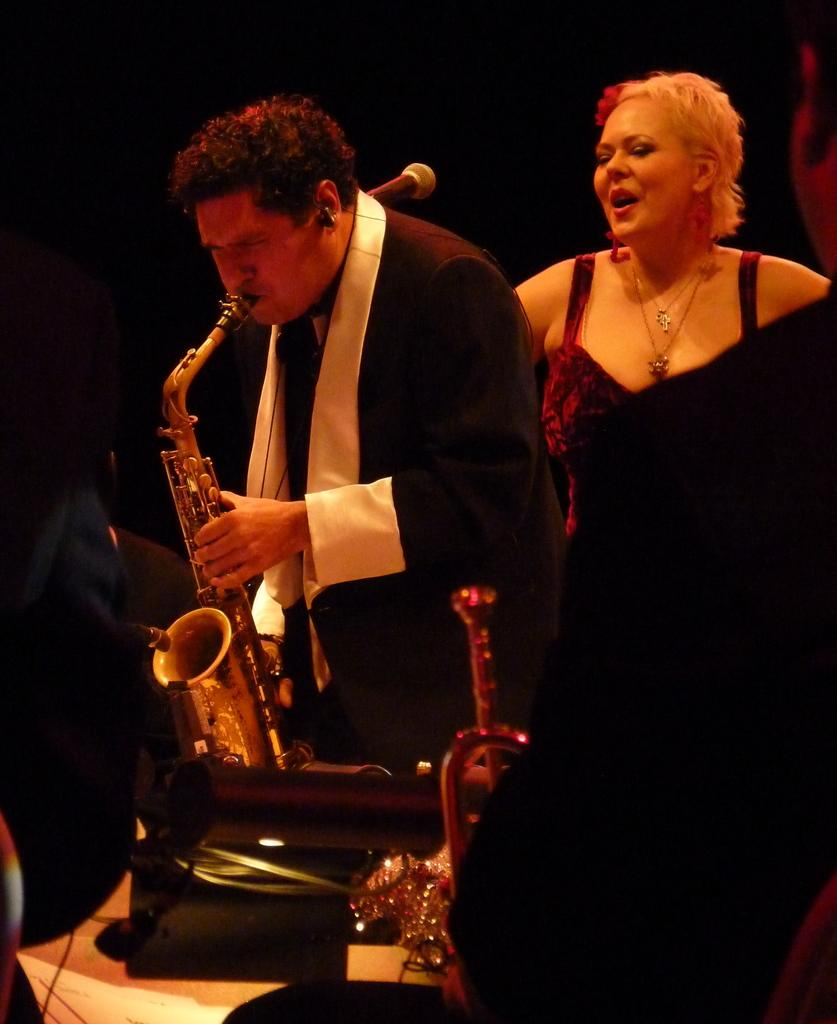What is the man in the image doing? The man is playing a saxophone. What is the man wearing in the image? The man is wearing a black suit. What is the woman's expression in the image? The woman is standing and smiling. What can be observed about the background of the image? The background of the image is dark. What type of boundary can be seen in the image? There is no boundary present in the image. What role does oil play in the image? There is no mention of oil in the image. 